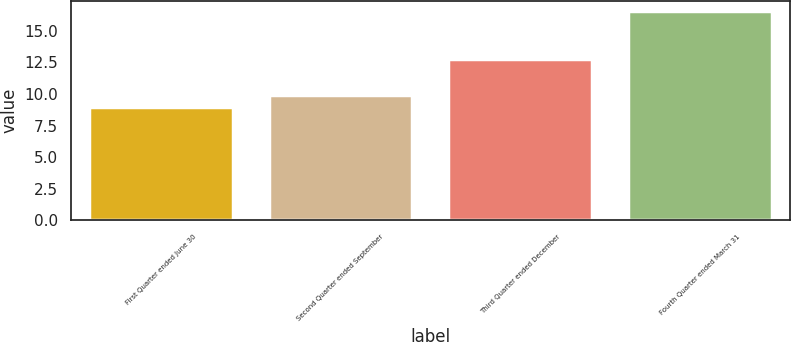Convert chart to OTSL. <chart><loc_0><loc_0><loc_500><loc_500><bar_chart><fcel>First Quarter ended June 30<fcel>Second Quarter ended September<fcel>Third Quarter ended December<fcel>Fourth Quarter ended March 31<nl><fcel>8.99<fcel>9.91<fcel>12.73<fcel>16.52<nl></chart> 